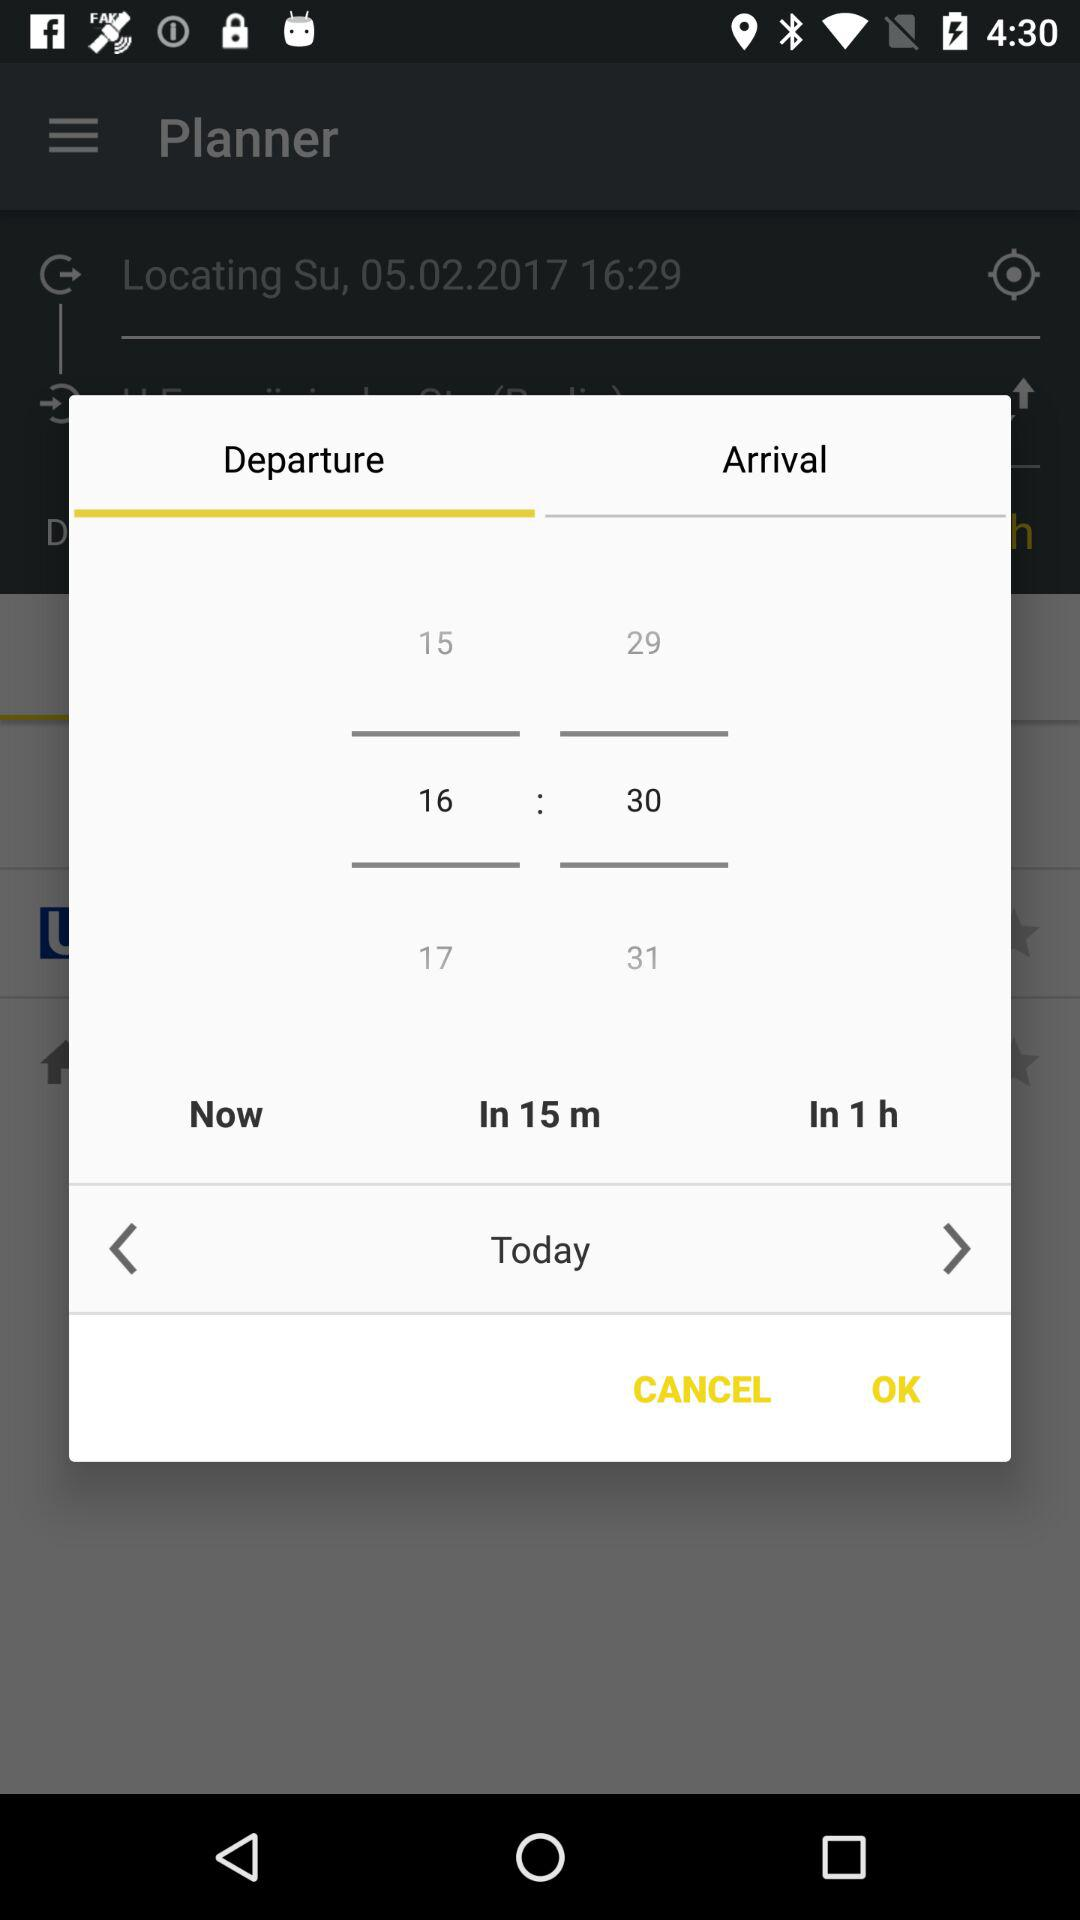What is the arrival time?
When the provided information is insufficient, respond with <no answer>. <no answer> 